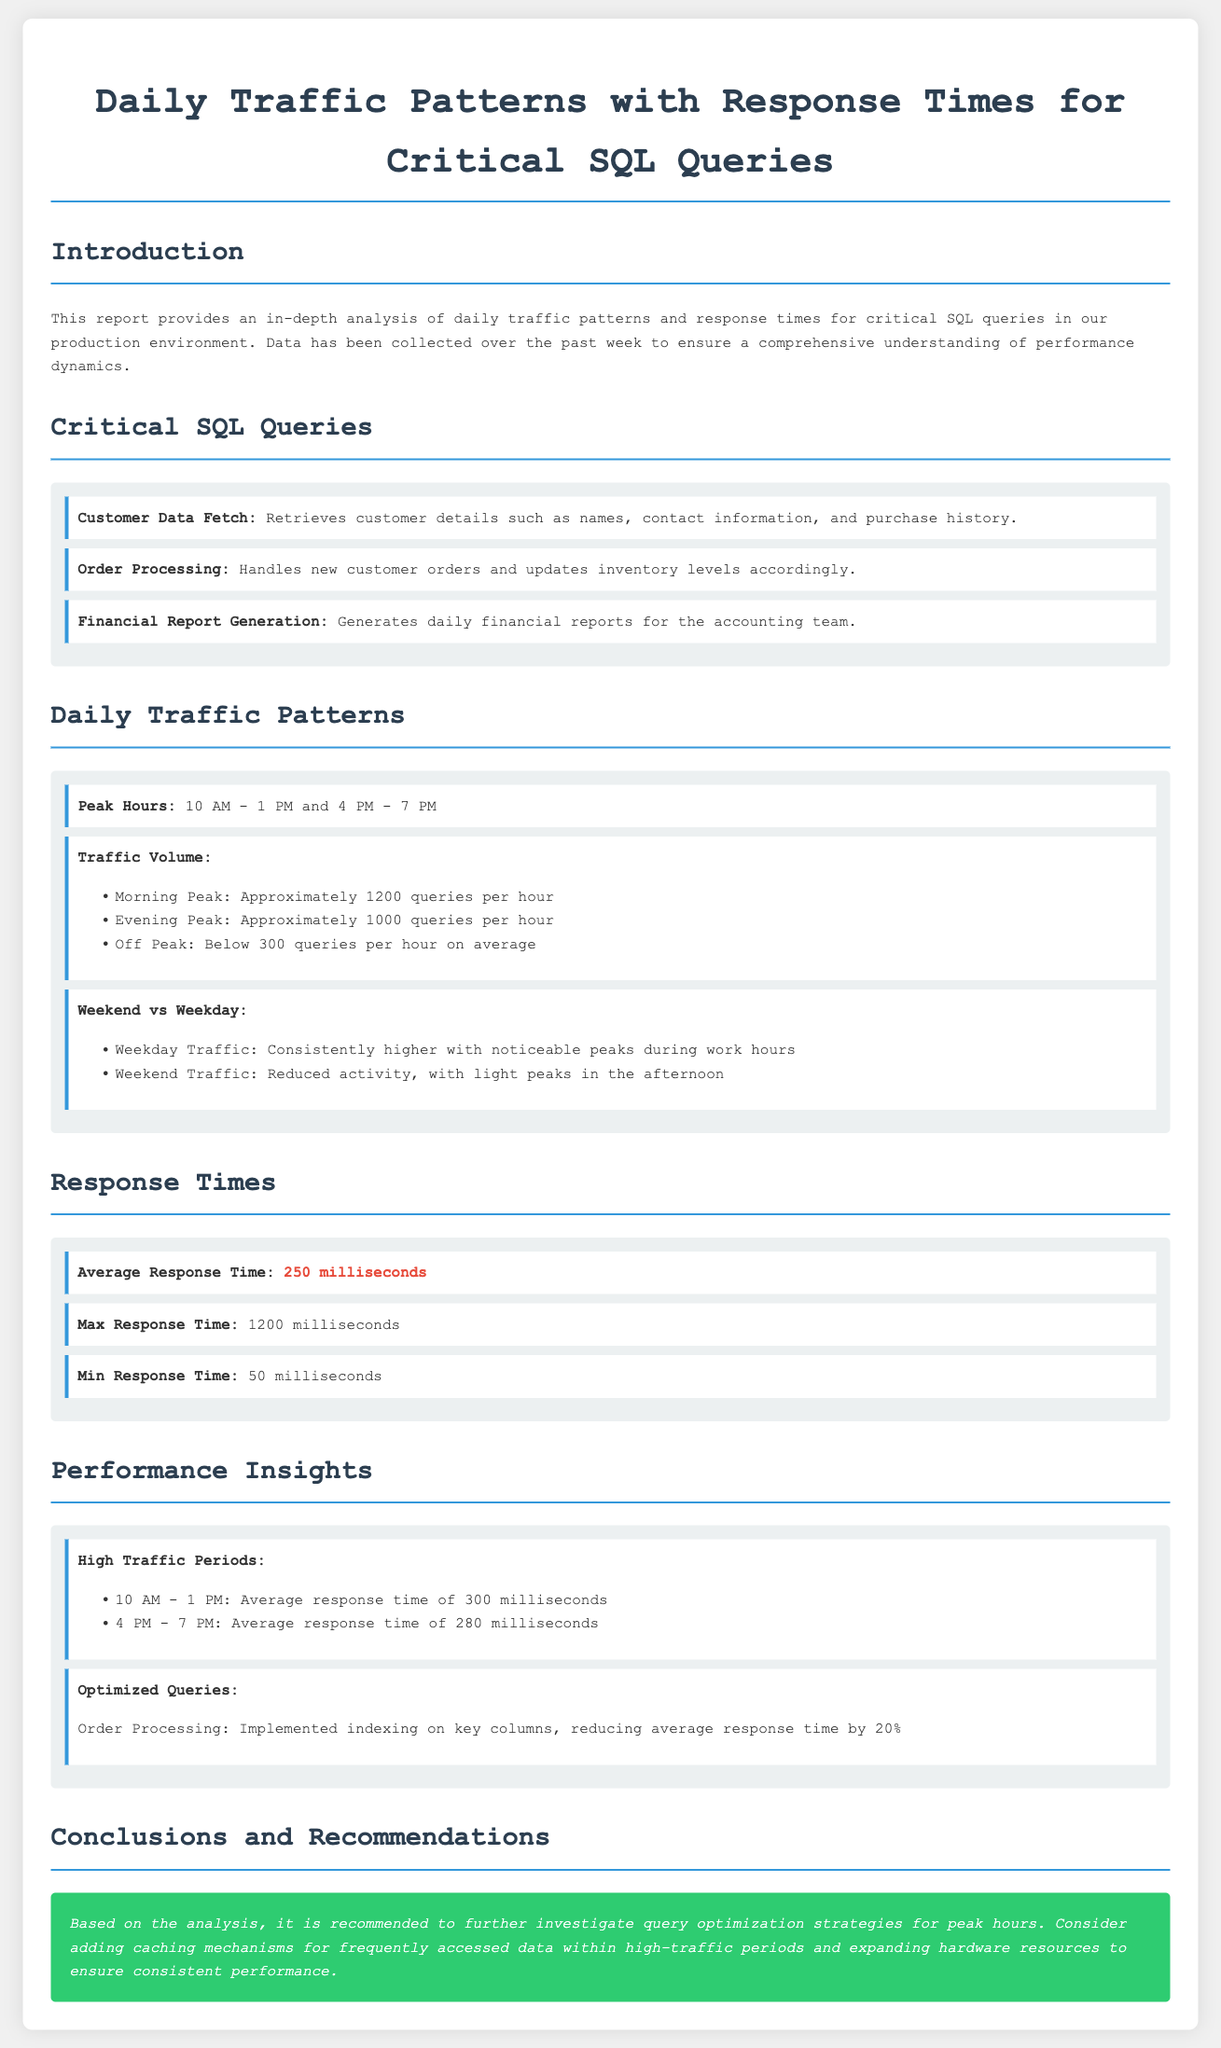What are the peak hours? The peak hours for traffic activity are specified in the document as high usage periods.
Answer: 10 AM - 1 PM and 4 PM - 7 PM What is the average response time for queries? The average response time is explicitly mentioned in the report.
Answer: 250 milliseconds Which SQL query has been optimized? The document highlights a particular query that underwent optimizations for performance.
Answer: Order Processing What was the maximum response time recorded? The document includes the maximum recorded time for query responses as part of the analysis.
Answer: 1200 milliseconds What is the traffic volume during the morning peak? The report provides specifics on traffic volume during peak hours, focusing on the morning period.
Answer: Approximately 1200 queries per hour What is the traffic pattern during weekends? The document presents a summary comparison of traffic patterns on weekends versus weekdays.
Answer: Reduced activity, with light peaks in the afternoon What is one recommendation made in the report? A recommendation is provided in the conclusions based on the analysis presented.
Answer: Investigate query optimization strategies for peak hours What is the minimum response time identified? The document clearly states the minimum response time recorded for the critical SQL queries.
Answer: 50 milliseconds 